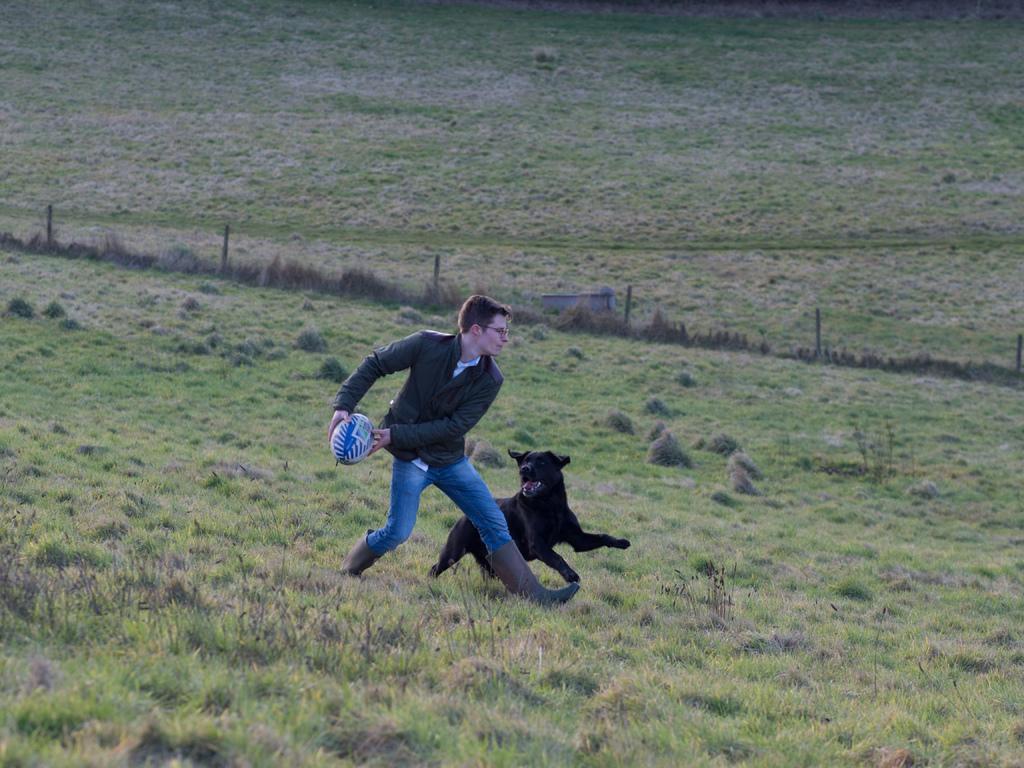Please provide a concise description of this image. In this image I can see a man is trying to throw a ball. He wore coat, trouser, shoes, beside him a dog is chasing. It is in black color, this is the grass in this image. 